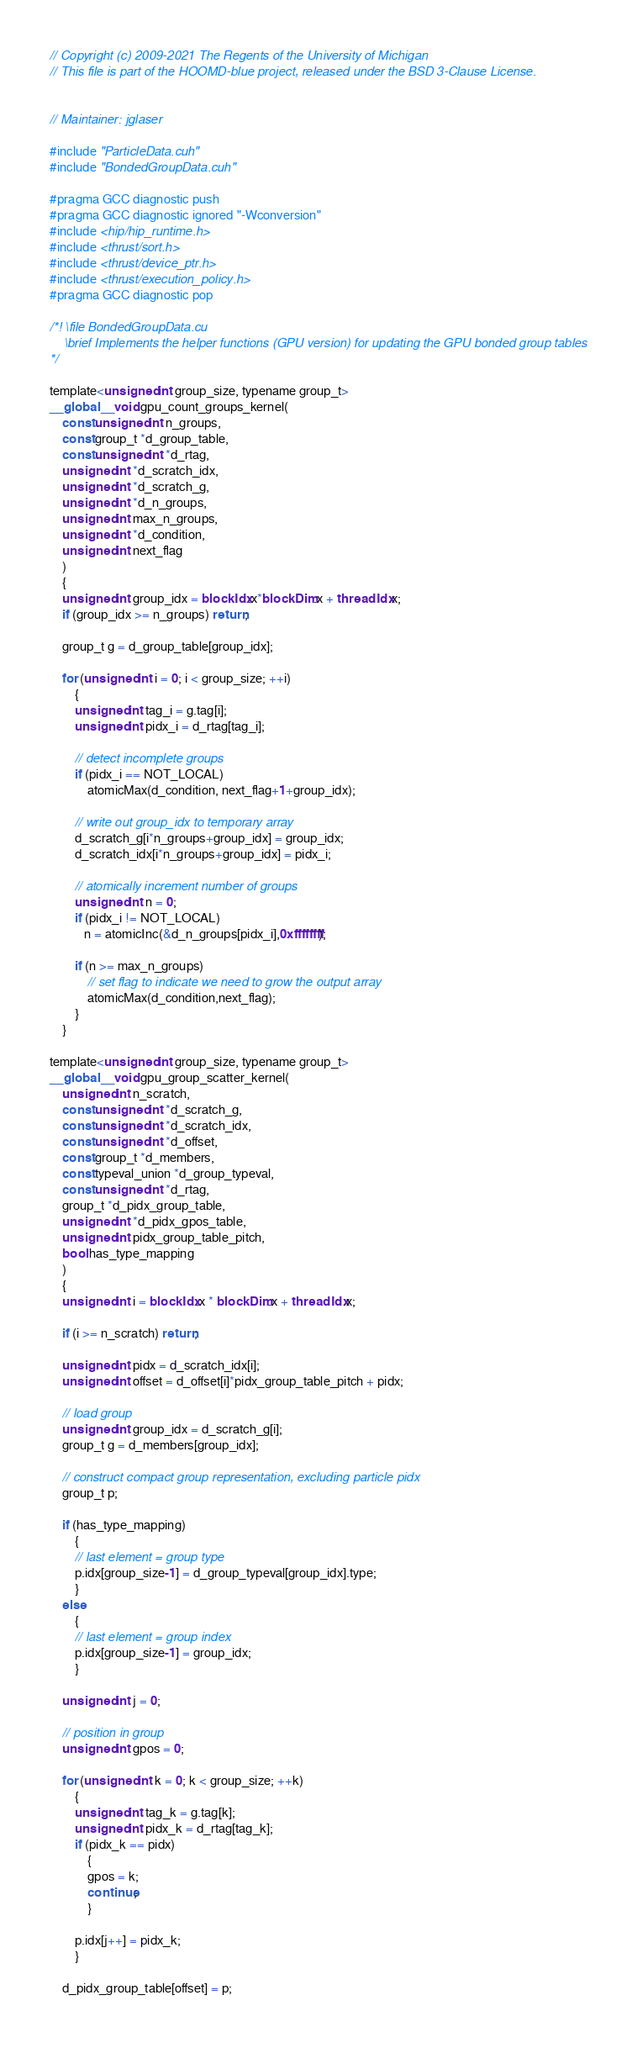<code> <loc_0><loc_0><loc_500><loc_500><_Cuda_>// Copyright (c) 2009-2021 The Regents of the University of Michigan
// This file is part of the HOOMD-blue project, released under the BSD 3-Clause License.


// Maintainer: jglaser

#include "ParticleData.cuh"
#include "BondedGroupData.cuh"

#pragma GCC diagnostic push
#pragma GCC diagnostic ignored "-Wconversion"
#include <hip/hip_runtime.h>
#include <thrust/sort.h>
#include <thrust/device_ptr.h>
#include <thrust/execution_policy.h>
#pragma GCC diagnostic pop

/*! \file BondedGroupData.cu
    \brief Implements the helper functions (GPU version) for updating the GPU bonded group tables
*/

template<unsigned int group_size, typename group_t>
__global__ void gpu_count_groups_kernel(
    const unsigned int n_groups,
    const group_t *d_group_table,
    const unsigned int *d_rtag,
    unsigned int *d_scratch_idx,
    unsigned int *d_scratch_g,
    unsigned int *d_n_groups,
    unsigned int max_n_groups,
    unsigned int *d_condition,
    unsigned int next_flag
    )
    {
    unsigned int group_idx = blockIdx.x*blockDim.x + threadIdx.x;
    if (group_idx >= n_groups) return;

    group_t g = d_group_table[group_idx];

    for (unsigned int i = 0; i < group_size; ++i)
        {
        unsigned int tag_i = g.tag[i];
        unsigned int pidx_i = d_rtag[tag_i];

        // detect incomplete groups
        if (pidx_i == NOT_LOCAL)
            atomicMax(d_condition, next_flag+1+group_idx);

        // write out group_idx to temporary array
        d_scratch_g[i*n_groups+group_idx] = group_idx;
        d_scratch_idx[i*n_groups+group_idx] = pidx_i;

        // atomically increment number of groups
        unsigned int n = 0;
        if (pidx_i != NOT_LOCAL)
           n = atomicInc(&d_n_groups[pidx_i],0xffffffff);

        if (n >= max_n_groups)
            // set flag to indicate we need to grow the output array
            atomicMax(d_condition,next_flag);
        }
    }

template<unsigned int group_size, typename group_t>
__global__ void gpu_group_scatter_kernel(
    unsigned int n_scratch,
    const unsigned int *d_scratch_g,
    const unsigned int *d_scratch_idx,
    const unsigned int *d_offset,
    const group_t *d_members,
    const typeval_union *d_group_typeval,
    const unsigned int *d_rtag,
    group_t *d_pidx_group_table,
    unsigned int *d_pidx_gpos_table,
    unsigned int pidx_group_table_pitch,
    bool has_type_mapping
    )
    {
    unsigned int i = blockIdx.x * blockDim.x + threadIdx.x;

    if (i >= n_scratch) return;

    unsigned int pidx = d_scratch_idx[i];
    unsigned int offset = d_offset[i]*pidx_group_table_pitch + pidx;

    // load group
    unsigned int group_idx = d_scratch_g[i];
    group_t g = d_members[group_idx];

    // construct compact group representation, excluding particle pidx
    group_t p;

    if (has_type_mapping)
        {
        // last element = group type
        p.idx[group_size-1] = d_group_typeval[group_idx].type;
        }
    else
        {
        // last element = group index
        p.idx[group_size-1] = group_idx;
        }

    unsigned int j = 0;

    // position in group
    unsigned int gpos = 0;

    for (unsigned int k = 0; k < group_size; ++k)
        {
        unsigned int tag_k = g.tag[k];
        unsigned int pidx_k = d_rtag[tag_k];
        if (pidx_k == pidx)
            {
            gpos = k;
            continue;
            }

        p.idx[j++] = pidx_k;
        }

    d_pidx_group_table[offset] = p;</code> 